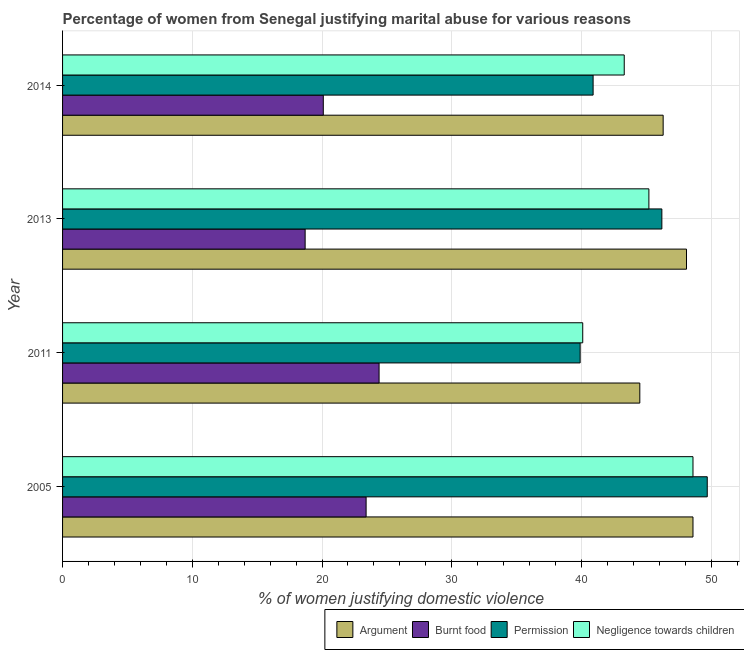Are the number of bars per tick equal to the number of legend labels?
Ensure brevity in your answer.  Yes. Are the number of bars on each tick of the Y-axis equal?
Provide a short and direct response. Yes. How many bars are there on the 1st tick from the bottom?
Provide a short and direct response. 4. What is the percentage of women justifying abuse for burning food in 2005?
Ensure brevity in your answer.  23.4. Across all years, what is the maximum percentage of women justifying abuse in the case of an argument?
Give a very brief answer. 48.6. Across all years, what is the minimum percentage of women justifying abuse in the case of an argument?
Offer a terse response. 44.5. In which year was the percentage of women justifying abuse in the case of an argument maximum?
Provide a short and direct response. 2005. What is the total percentage of women justifying abuse for showing negligence towards children in the graph?
Provide a short and direct response. 177.2. What is the difference between the percentage of women justifying abuse for going without permission in 2005 and that in 2013?
Give a very brief answer. 3.5. What is the difference between the percentage of women justifying abuse in the case of an argument in 2014 and the percentage of women justifying abuse for going without permission in 2013?
Your answer should be compact. 0.1. What is the average percentage of women justifying abuse in the case of an argument per year?
Provide a succinct answer. 46.88. In the year 2013, what is the difference between the percentage of women justifying abuse for burning food and percentage of women justifying abuse in the case of an argument?
Provide a succinct answer. -29.4. In how many years, is the percentage of women justifying abuse for burning food greater than 36 %?
Make the answer very short. 0. What is the ratio of the percentage of women justifying abuse for going without permission in 2005 to that in 2014?
Keep it short and to the point. 1.22. Is the difference between the percentage of women justifying abuse for burning food in 2011 and 2013 greater than the difference between the percentage of women justifying abuse for showing negligence towards children in 2011 and 2013?
Keep it short and to the point. Yes. What is the difference between the highest and the lowest percentage of women justifying abuse in the case of an argument?
Provide a short and direct response. 4.1. Is the sum of the percentage of women justifying abuse for showing negligence towards children in 2005 and 2011 greater than the maximum percentage of women justifying abuse in the case of an argument across all years?
Keep it short and to the point. Yes. What does the 4th bar from the top in 2014 represents?
Offer a terse response. Argument. What does the 3rd bar from the bottom in 2013 represents?
Offer a very short reply. Permission. How many bars are there?
Provide a short and direct response. 16. Are all the bars in the graph horizontal?
Offer a very short reply. Yes. Does the graph contain grids?
Offer a very short reply. Yes. Where does the legend appear in the graph?
Ensure brevity in your answer.  Bottom right. How many legend labels are there?
Offer a very short reply. 4. What is the title of the graph?
Keep it short and to the point. Percentage of women from Senegal justifying marital abuse for various reasons. What is the label or title of the X-axis?
Provide a short and direct response. % of women justifying domestic violence. What is the % of women justifying domestic violence in Argument in 2005?
Keep it short and to the point. 48.6. What is the % of women justifying domestic violence in Burnt food in 2005?
Your answer should be compact. 23.4. What is the % of women justifying domestic violence of Permission in 2005?
Give a very brief answer. 49.7. What is the % of women justifying domestic violence in Negligence towards children in 2005?
Provide a short and direct response. 48.6. What is the % of women justifying domestic violence in Argument in 2011?
Keep it short and to the point. 44.5. What is the % of women justifying domestic violence of Burnt food in 2011?
Ensure brevity in your answer.  24.4. What is the % of women justifying domestic violence of Permission in 2011?
Your answer should be very brief. 39.9. What is the % of women justifying domestic violence in Negligence towards children in 2011?
Provide a succinct answer. 40.1. What is the % of women justifying domestic violence of Argument in 2013?
Make the answer very short. 48.1. What is the % of women justifying domestic violence of Burnt food in 2013?
Make the answer very short. 18.7. What is the % of women justifying domestic violence of Permission in 2013?
Offer a terse response. 46.2. What is the % of women justifying domestic violence of Negligence towards children in 2013?
Offer a very short reply. 45.2. What is the % of women justifying domestic violence in Argument in 2014?
Your answer should be compact. 46.3. What is the % of women justifying domestic violence in Burnt food in 2014?
Keep it short and to the point. 20.1. What is the % of women justifying domestic violence of Permission in 2014?
Give a very brief answer. 40.9. What is the % of women justifying domestic violence of Negligence towards children in 2014?
Offer a terse response. 43.3. Across all years, what is the maximum % of women justifying domestic violence in Argument?
Offer a terse response. 48.6. Across all years, what is the maximum % of women justifying domestic violence in Burnt food?
Your answer should be very brief. 24.4. Across all years, what is the maximum % of women justifying domestic violence of Permission?
Make the answer very short. 49.7. Across all years, what is the maximum % of women justifying domestic violence of Negligence towards children?
Make the answer very short. 48.6. Across all years, what is the minimum % of women justifying domestic violence of Argument?
Make the answer very short. 44.5. Across all years, what is the minimum % of women justifying domestic violence of Burnt food?
Give a very brief answer. 18.7. Across all years, what is the minimum % of women justifying domestic violence of Permission?
Your response must be concise. 39.9. Across all years, what is the minimum % of women justifying domestic violence of Negligence towards children?
Give a very brief answer. 40.1. What is the total % of women justifying domestic violence of Argument in the graph?
Make the answer very short. 187.5. What is the total % of women justifying domestic violence in Burnt food in the graph?
Provide a short and direct response. 86.6. What is the total % of women justifying domestic violence in Permission in the graph?
Offer a terse response. 176.7. What is the total % of women justifying domestic violence in Negligence towards children in the graph?
Offer a terse response. 177.2. What is the difference between the % of women justifying domestic violence of Argument in 2005 and that in 2011?
Provide a succinct answer. 4.1. What is the difference between the % of women justifying domestic violence of Burnt food in 2005 and that in 2011?
Ensure brevity in your answer.  -1. What is the difference between the % of women justifying domestic violence in Argument in 2005 and that in 2013?
Your response must be concise. 0.5. What is the difference between the % of women justifying domestic violence of Argument in 2005 and that in 2014?
Provide a short and direct response. 2.3. What is the difference between the % of women justifying domestic violence in Permission in 2005 and that in 2014?
Offer a very short reply. 8.8. What is the difference between the % of women justifying domestic violence of Negligence towards children in 2005 and that in 2014?
Keep it short and to the point. 5.3. What is the difference between the % of women justifying domestic violence of Burnt food in 2011 and that in 2013?
Ensure brevity in your answer.  5.7. What is the difference between the % of women justifying domestic violence in Burnt food in 2011 and that in 2014?
Your answer should be very brief. 4.3. What is the difference between the % of women justifying domestic violence in Permission in 2011 and that in 2014?
Offer a very short reply. -1. What is the difference between the % of women justifying domestic violence in Argument in 2013 and that in 2014?
Provide a short and direct response. 1.8. What is the difference between the % of women justifying domestic violence in Permission in 2013 and that in 2014?
Offer a very short reply. 5.3. What is the difference between the % of women justifying domestic violence of Negligence towards children in 2013 and that in 2014?
Provide a short and direct response. 1.9. What is the difference between the % of women justifying domestic violence in Argument in 2005 and the % of women justifying domestic violence in Burnt food in 2011?
Ensure brevity in your answer.  24.2. What is the difference between the % of women justifying domestic violence of Argument in 2005 and the % of women justifying domestic violence of Permission in 2011?
Offer a terse response. 8.7. What is the difference between the % of women justifying domestic violence in Burnt food in 2005 and the % of women justifying domestic violence in Permission in 2011?
Offer a very short reply. -16.5. What is the difference between the % of women justifying domestic violence in Burnt food in 2005 and the % of women justifying domestic violence in Negligence towards children in 2011?
Your answer should be compact. -16.7. What is the difference between the % of women justifying domestic violence in Argument in 2005 and the % of women justifying domestic violence in Burnt food in 2013?
Provide a succinct answer. 29.9. What is the difference between the % of women justifying domestic violence of Argument in 2005 and the % of women justifying domestic violence of Permission in 2013?
Your answer should be compact. 2.4. What is the difference between the % of women justifying domestic violence in Argument in 2005 and the % of women justifying domestic violence in Negligence towards children in 2013?
Give a very brief answer. 3.4. What is the difference between the % of women justifying domestic violence of Burnt food in 2005 and the % of women justifying domestic violence of Permission in 2013?
Your answer should be very brief. -22.8. What is the difference between the % of women justifying domestic violence of Burnt food in 2005 and the % of women justifying domestic violence of Negligence towards children in 2013?
Give a very brief answer. -21.8. What is the difference between the % of women justifying domestic violence of Permission in 2005 and the % of women justifying domestic violence of Negligence towards children in 2013?
Provide a short and direct response. 4.5. What is the difference between the % of women justifying domestic violence of Argument in 2005 and the % of women justifying domestic violence of Burnt food in 2014?
Provide a succinct answer. 28.5. What is the difference between the % of women justifying domestic violence in Argument in 2005 and the % of women justifying domestic violence in Permission in 2014?
Your response must be concise. 7.7. What is the difference between the % of women justifying domestic violence in Argument in 2005 and the % of women justifying domestic violence in Negligence towards children in 2014?
Offer a very short reply. 5.3. What is the difference between the % of women justifying domestic violence of Burnt food in 2005 and the % of women justifying domestic violence of Permission in 2014?
Offer a very short reply. -17.5. What is the difference between the % of women justifying domestic violence in Burnt food in 2005 and the % of women justifying domestic violence in Negligence towards children in 2014?
Your answer should be very brief. -19.9. What is the difference between the % of women justifying domestic violence of Argument in 2011 and the % of women justifying domestic violence of Burnt food in 2013?
Keep it short and to the point. 25.8. What is the difference between the % of women justifying domestic violence in Argument in 2011 and the % of women justifying domestic violence in Permission in 2013?
Make the answer very short. -1.7. What is the difference between the % of women justifying domestic violence in Burnt food in 2011 and the % of women justifying domestic violence in Permission in 2013?
Your answer should be very brief. -21.8. What is the difference between the % of women justifying domestic violence in Burnt food in 2011 and the % of women justifying domestic violence in Negligence towards children in 2013?
Your response must be concise. -20.8. What is the difference between the % of women justifying domestic violence of Argument in 2011 and the % of women justifying domestic violence of Burnt food in 2014?
Your answer should be very brief. 24.4. What is the difference between the % of women justifying domestic violence in Argument in 2011 and the % of women justifying domestic violence in Permission in 2014?
Ensure brevity in your answer.  3.6. What is the difference between the % of women justifying domestic violence in Burnt food in 2011 and the % of women justifying domestic violence in Permission in 2014?
Offer a very short reply. -16.5. What is the difference between the % of women justifying domestic violence in Burnt food in 2011 and the % of women justifying domestic violence in Negligence towards children in 2014?
Provide a short and direct response. -18.9. What is the difference between the % of women justifying domestic violence of Permission in 2011 and the % of women justifying domestic violence of Negligence towards children in 2014?
Make the answer very short. -3.4. What is the difference between the % of women justifying domestic violence in Argument in 2013 and the % of women justifying domestic violence in Negligence towards children in 2014?
Offer a very short reply. 4.8. What is the difference between the % of women justifying domestic violence in Burnt food in 2013 and the % of women justifying domestic violence in Permission in 2014?
Offer a terse response. -22.2. What is the difference between the % of women justifying domestic violence of Burnt food in 2013 and the % of women justifying domestic violence of Negligence towards children in 2014?
Keep it short and to the point. -24.6. What is the average % of women justifying domestic violence in Argument per year?
Your response must be concise. 46.88. What is the average % of women justifying domestic violence in Burnt food per year?
Keep it short and to the point. 21.65. What is the average % of women justifying domestic violence in Permission per year?
Ensure brevity in your answer.  44.17. What is the average % of women justifying domestic violence in Negligence towards children per year?
Offer a very short reply. 44.3. In the year 2005, what is the difference between the % of women justifying domestic violence in Argument and % of women justifying domestic violence in Burnt food?
Offer a very short reply. 25.2. In the year 2005, what is the difference between the % of women justifying domestic violence in Argument and % of women justifying domestic violence in Permission?
Keep it short and to the point. -1.1. In the year 2005, what is the difference between the % of women justifying domestic violence of Burnt food and % of women justifying domestic violence of Permission?
Keep it short and to the point. -26.3. In the year 2005, what is the difference between the % of women justifying domestic violence in Burnt food and % of women justifying domestic violence in Negligence towards children?
Your response must be concise. -25.2. In the year 2005, what is the difference between the % of women justifying domestic violence in Permission and % of women justifying domestic violence in Negligence towards children?
Your answer should be very brief. 1.1. In the year 2011, what is the difference between the % of women justifying domestic violence in Argument and % of women justifying domestic violence in Burnt food?
Your response must be concise. 20.1. In the year 2011, what is the difference between the % of women justifying domestic violence in Argument and % of women justifying domestic violence in Negligence towards children?
Offer a very short reply. 4.4. In the year 2011, what is the difference between the % of women justifying domestic violence in Burnt food and % of women justifying domestic violence in Permission?
Your answer should be compact. -15.5. In the year 2011, what is the difference between the % of women justifying domestic violence of Burnt food and % of women justifying domestic violence of Negligence towards children?
Make the answer very short. -15.7. In the year 2013, what is the difference between the % of women justifying domestic violence in Argument and % of women justifying domestic violence in Burnt food?
Keep it short and to the point. 29.4. In the year 2013, what is the difference between the % of women justifying domestic violence of Burnt food and % of women justifying domestic violence of Permission?
Your response must be concise. -27.5. In the year 2013, what is the difference between the % of women justifying domestic violence of Burnt food and % of women justifying domestic violence of Negligence towards children?
Make the answer very short. -26.5. In the year 2013, what is the difference between the % of women justifying domestic violence in Permission and % of women justifying domestic violence in Negligence towards children?
Provide a succinct answer. 1. In the year 2014, what is the difference between the % of women justifying domestic violence in Argument and % of women justifying domestic violence in Burnt food?
Ensure brevity in your answer.  26.2. In the year 2014, what is the difference between the % of women justifying domestic violence of Argument and % of women justifying domestic violence of Permission?
Your answer should be very brief. 5.4. In the year 2014, what is the difference between the % of women justifying domestic violence in Argument and % of women justifying domestic violence in Negligence towards children?
Provide a succinct answer. 3. In the year 2014, what is the difference between the % of women justifying domestic violence in Burnt food and % of women justifying domestic violence in Permission?
Offer a terse response. -20.8. In the year 2014, what is the difference between the % of women justifying domestic violence of Burnt food and % of women justifying domestic violence of Negligence towards children?
Your answer should be compact. -23.2. What is the ratio of the % of women justifying domestic violence of Argument in 2005 to that in 2011?
Ensure brevity in your answer.  1.09. What is the ratio of the % of women justifying domestic violence of Burnt food in 2005 to that in 2011?
Offer a terse response. 0.96. What is the ratio of the % of women justifying domestic violence in Permission in 2005 to that in 2011?
Your answer should be compact. 1.25. What is the ratio of the % of women justifying domestic violence in Negligence towards children in 2005 to that in 2011?
Provide a succinct answer. 1.21. What is the ratio of the % of women justifying domestic violence in Argument in 2005 to that in 2013?
Your answer should be compact. 1.01. What is the ratio of the % of women justifying domestic violence in Burnt food in 2005 to that in 2013?
Keep it short and to the point. 1.25. What is the ratio of the % of women justifying domestic violence of Permission in 2005 to that in 2013?
Your answer should be very brief. 1.08. What is the ratio of the % of women justifying domestic violence in Negligence towards children in 2005 to that in 2013?
Keep it short and to the point. 1.08. What is the ratio of the % of women justifying domestic violence in Argument in 2005 to that in 2014?
Provide a succinct answer. 1.05. What is the ratio of the % of women justifying domestic violence in Burnt food in 2005 to that in 2014?
Give a very brief answer. 1.16. What is the ratio of the % of women justifying domestic violence of Permission in 2005 to that in 2014?
Offer a very short reply. 1.22. What is the ratio of the % of women justifying domestic violence of Negligence towards children in 2005 to that in 2014?
Make the answer very short. 1.12. What is the ratio of the % of women justifying domestic violence of Argument in 2011 to that in 2013?
Make the answer very short. 0.93. What is the ratio of the % of women justifying domestic violence of Burnt food in 2011 to that in 2013?
Offer a terse response. 1.3. What is the ratio of the % of women justifying domestic violence of Permission in 2011 to that in 2013?
Provide a succinct answer. 0.86. What is the ratio of the % of women justifying domestic violence in Negligence towards children in 2011 to that in 2013?
Your answer should be very brief. 0.89. What is the ratio of the % of women justifying domestic violence of Argument in 2011 to that in 2014?
Give a very brief answer. 0.96. What is the ratio of the % of women justifying domestic violence in Burnt food in 2011 to that in 2014?
Your response must be concise. 1.21. What is the ratio of the % of women justifying domestic violence of Permission in 2011 to that in 2014?
Offer a terse response. 0.98. What is the ratio of the % of women justifying domestic violence of Negligence towards children in 2011 to that in 2014?
Your answer should be very brief. 0.93. What is the ratio of the % of women justifying domestic violence in Argument in 2013 to that in 2014?
Your answer should be very brief. 1.04. What is the ratio of the % of women justifying domestic violence in Burnt food in 2013 to that in 2014?
Keep it short and to the point. 0.93. What is the ratio of the % of women justifying domestic violence of Permission in 2013 to that in 2014?
Provide a short and direct response. 1.13. What is the ratio of the % of women justifying domestic violence in Negligence towards children in 2013 to that in 2014?
Keep it short and to the point. 1.04. What is the difference between the highest and the second highest % of women justifying domestic violence in Permission?
Your response must be concise. 3.5. What is the difference between the highest and the second highest % of women justifying domestic violence in Negligence towards children?
Your response must be concise. 3.4. What is the difference between the highest and the lowest % of women justifying domestic violence of Argument?
Ensure brevity in your answer.  4.1. What is the difference between the highest and the lowest % of women justifying domestic violence in Negligence towards children?
Offer a very short reply. 8.5. 